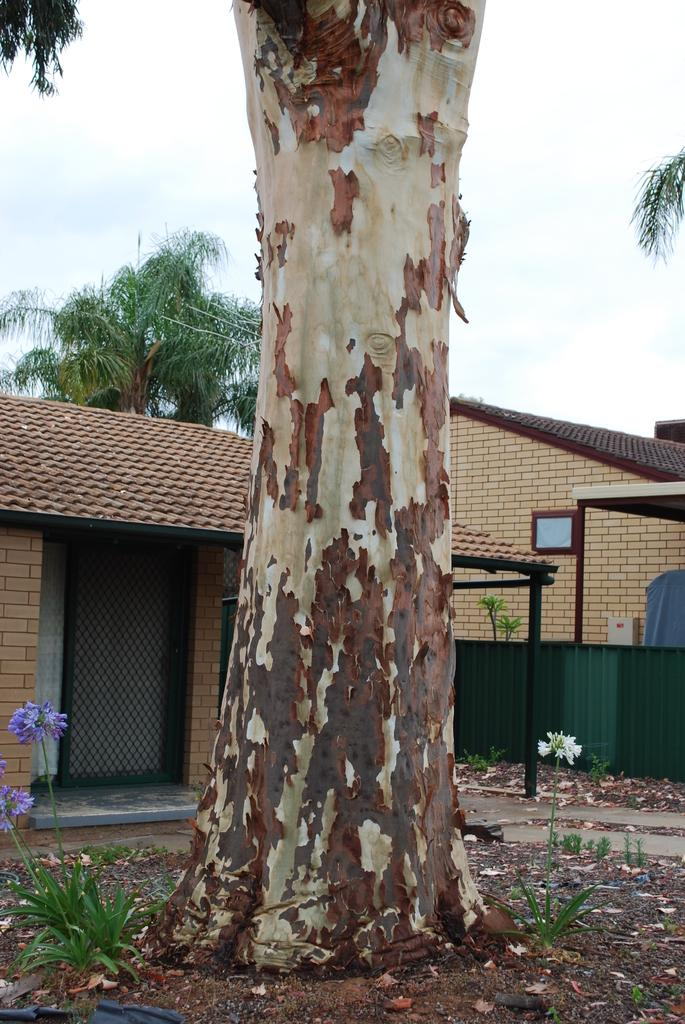What can be seen in the sky in the image? The sky is visible in the image. What type of natural elements are present in the image? There are trees in the image. What type of man-made structures can be seen in the image? There are buildings in the image. What type of vertical structures are present in the image? There are poles in the image. What type of debris or plant material can be seen on the ground in the image? Shredded leaves are present in the image. What is visible at the bottom of the image? The ground is visible in the image. How many planes are flying in the sky in the image? There are no planes visible in the sky in the image. What type of death is depicted in the image? There is no depiction of death in the image. 